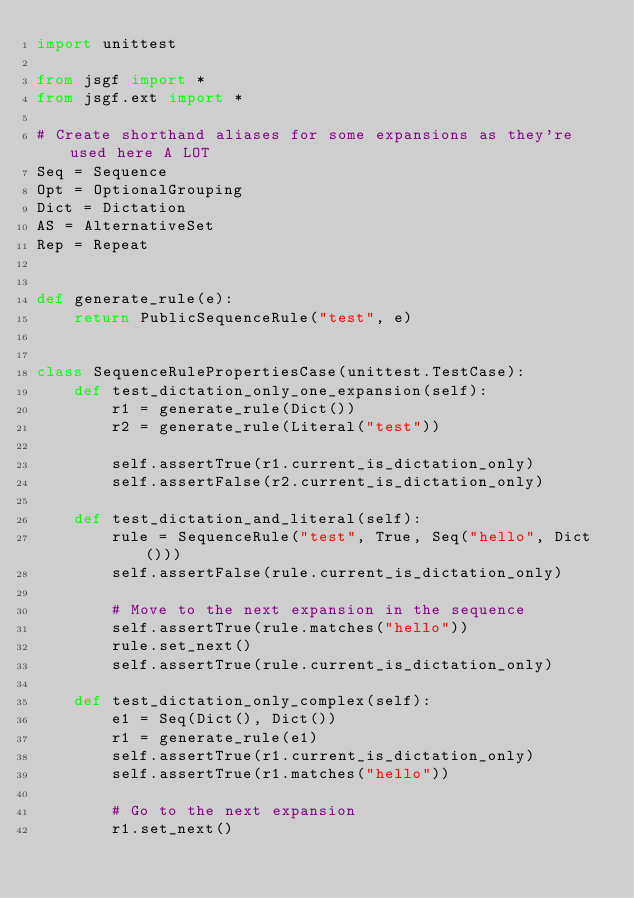Convert code to text. <code><loc_0><loc_0><loc_500><loc_500><_Python_>import unittest

from jsgf import *
from jsgf.ext import *

# Create shorthand aliases for some expansions as they're used here A LOT
Seq = Sequence
Opt = OptionalGrouping
Dict = Dictation
AS = AlternativeSet
Rep = Repeat


def generate_rule(e):
    return PublicSequenceRule("test", e)


class SequenceRulePropertiesCase(unittest.TestCase):
    def test_dictation_only_one_expansion(self):
        r1 = generate_rule(Dict())
        r2 = generate_rule(Literal("test"))

        self.assertTrue(r1.current_is_dictation_only)
        self.assertFalse(r2.current_is_dictation_only)

    def test_dictation_and_literal(self):
        rule = SequenceRule("test", True, Seq("hello", Dict()))
        self.assertFalse(rule.current_is_dictation_only)

        # Move to the next expansion in the sequence
        self.assertTrue(rule.matches("hello"))
        rule.set_next()
        self.assertTrue(rule.current_is_dictation_only)

    def test_dictation_only_complex(self):
        e1 = Seq(Dict(), Dict())
        r1 = generate_rule(e1)
        self.assertTrue(r1.current_is_dictation_only)
        self.assertTrue(r1.matches("hello"))

        # Go to the next expansion
        r1.set_next()</code> 